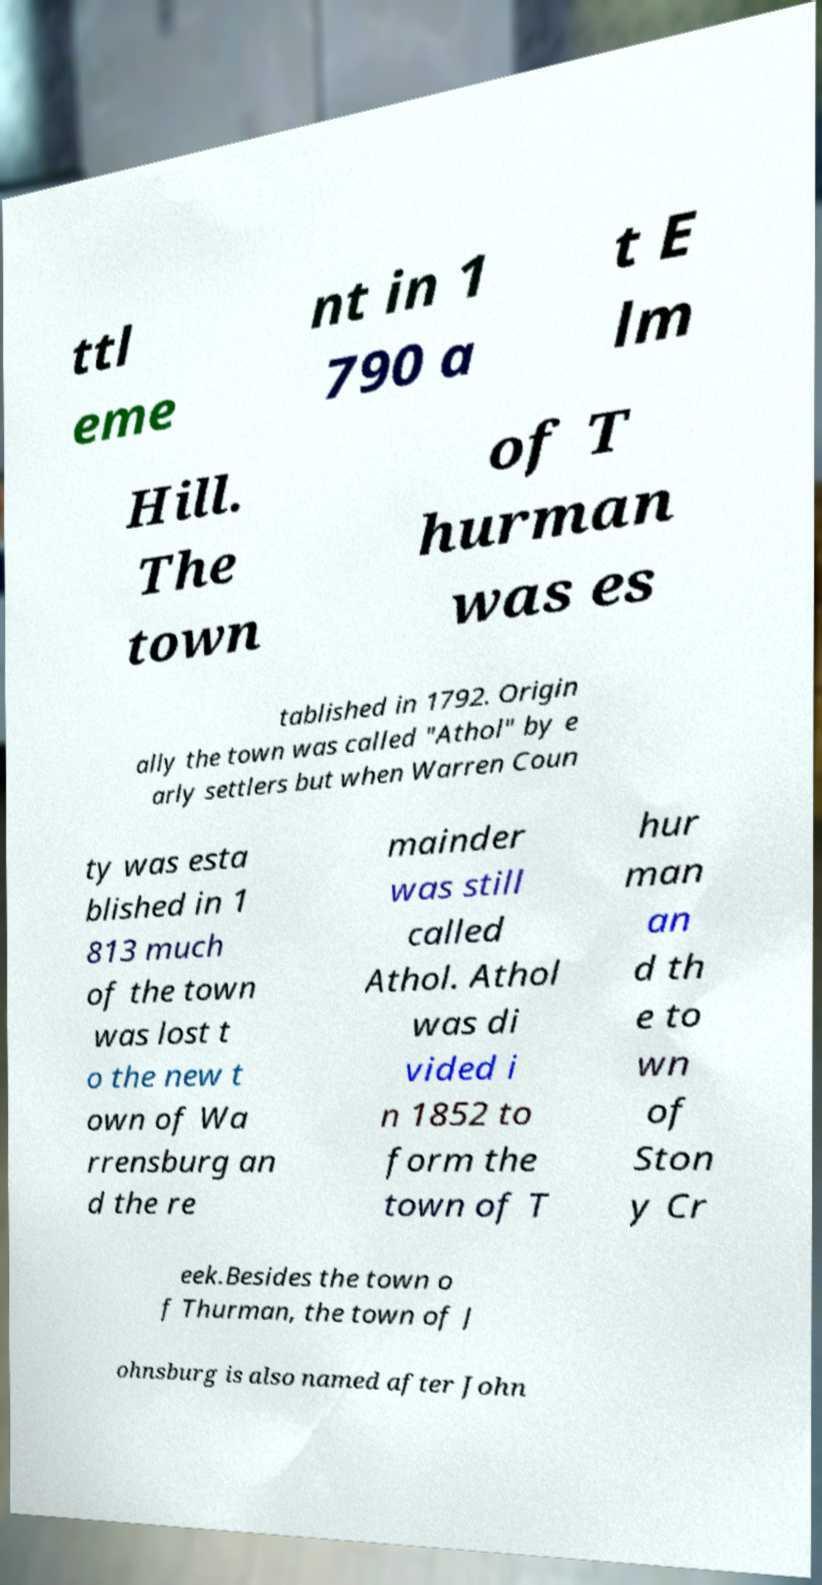Please read and relay the text visible in this image. What does it say? ttl eme nt in 1 790 a t E lm Hill. The town of T hurman was es tablished in 1792. Origin ally the town was called "Athol" by e arly settlers but when Warren Coun ty was esta blished in 1 813 much of the town was lost t o the new t own of Wa rrensburg an d the re mainder was still called Athol. Athol was di vided i n 1852 to form the town of T hur man an d th e to wn of Ston y Cr eek.Besides the town o f Thurman, the town of J ohnsburg is also named after John 